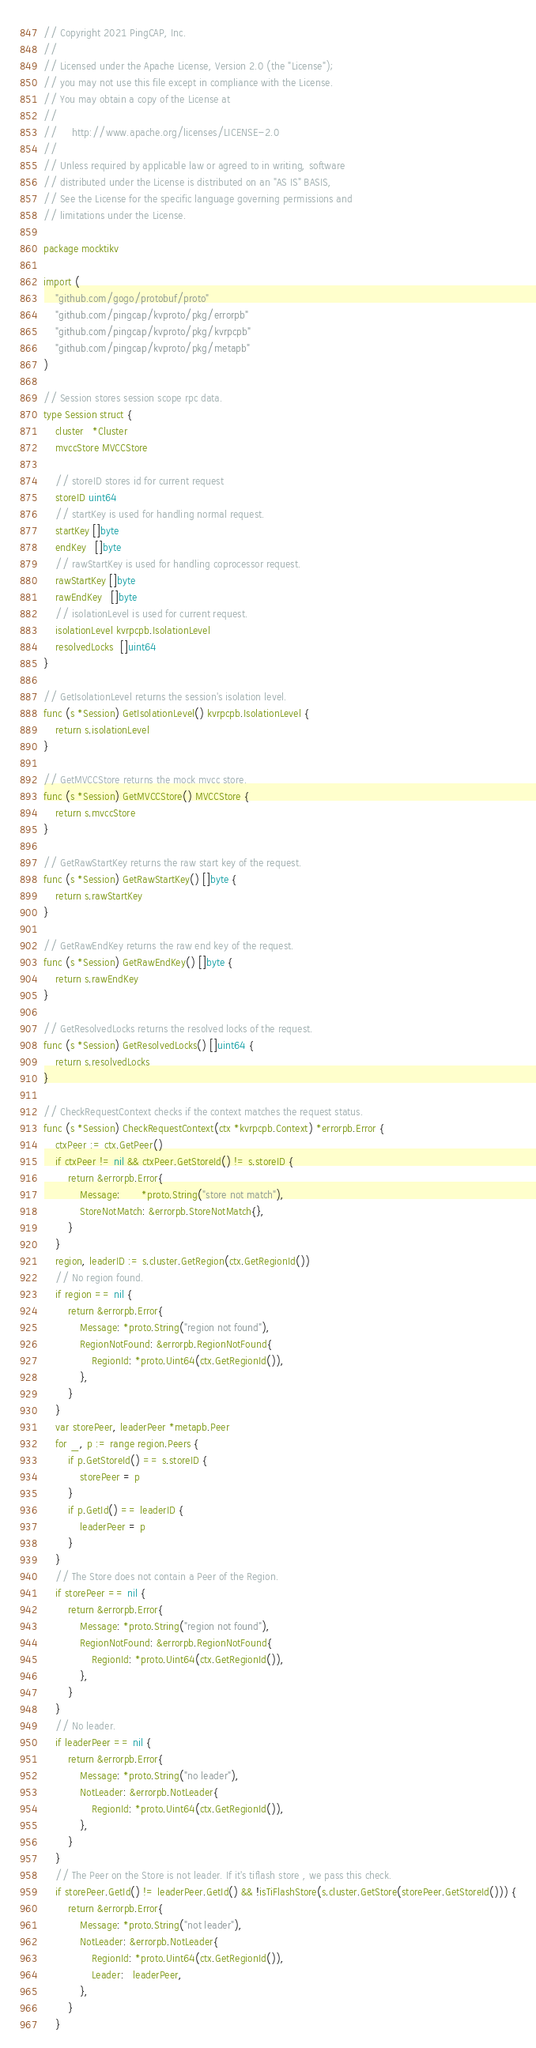<code> <loc_0><loc_0><loc_500><loc_500><_Go_>// Copyright 2021 PingCAP, Inc.
//
// Licensed under the Apache License, Version 2.0 (the "License");
// you may not use this file except in compliance with the License.
// You may obtain a copy of the License at
//
//     http://www.apache.org/licenses/LICENSE-2.0
//
// Unless required by applicable law or agreed to in writing, software
// distributed under the License is distributed on an "AS IS" BASIS,
// See the License for the specific language governing permissions and
// limitations under the License.

package mocktikv

import (
	"github.com/gogo/protobuf/proto"
	"github.com/pingcap/kvproto/pkg/errorpb"
	"github.com/pingcap/kvproto/pkg/kvrpcpb"
	"github.com/pingcap/kvproto/pkg/metapb"
)

// Session stores session scope rpc data.
type Session struct {
	cluster   *Cluster
	mvccStore MVCCStore

	// storeID stores id for current request
	storeID uint64
	// startKey is used for handling normal request.
	startKey []byte
	endKey   []byte
	// rawStartKey is used for handling coprocessor request.
	rawStartKey []byte
	rawEndKey   []byte
	// isolationLevel is used for current request.
	isolationLevel kvrpcpb.IsolationLevel
	resolvedLocks  []uint64
}

// GetIsolationLevel returns the session's isolation level.
func (s *Session) GetIsolationLevel() kvrpcpb.IsolationLevel {
	return s.isolationLevel
}

// GetMVCCStore returns the mock mvcc store.
func (s *Session) GetMVCCStore() MVCCStore {
	return s.mvccStore
}

// GetRawStartKey returns the raw start key of the request.
func (s *Session) GetRawStartKey() []byte {
	return s.rawStartKey
}

// GetRawEndKey returns the raw end key of the request.
func (s *Session) GetRawEndKey() []byte {
	return s.rawEndKey
}

// GetResolvedLocks returns the resolved locks of the request.
func (s *Session) GetResolvedLocks() []uint64 {
	return s.resolvedLocks
}

// CheckRequestContext checks if the context matches the request status.
func (s *Session) CheckRequestContext(ctx *kvrpcpb.Context) *errorpb.Error {
	ctxPeer := ctx.GetPeer()
	if ctxPeer != nil && ctxPeer.GetStoreId() != s.storeID {
		return &errorpb.Error{
			Message:       *proto.String("store not match"),
			StoreNotMatch: &errorpb.StoreNotMatch{},
		}
	}
	region, leaderID := s.cluster.GetRegion(ctx.GetRegionId())
	// No region found.
	if region == nil {
		return &errorpb.Error{
			Message: *proto.String("region not found"),
			RegionNotFound: &errorpb.RegionNotFound{
				RegionId: *proto.Uint64(ctx.GetRegionId()),
			},
		}
	}
	var storePeer, leaderPeer *metapb.Peer
	for _, p := range region.Peers {
		if p.GetStoreId() == s.storeID {
			storePeer = p
		}
		if p.GetId() == leaderID {
			leaderPeer = p
		}
	}
	// The Store does not contain a Peer of the Region.
	if storePeer == nil {
		return &errorpb.Error{
			Message: *proto.String("region not found"),
			RegionNotFound: &errorpb.RegionNotFound{
				RegionId: *proto.Uint64(ctx.GetRegionId()),
			},
		}
	}
	// No leader.
	if leaderPeer == nil {
		return &errorpb.Error{
			Message: *proto.String("no leader"),
			NotLeader: &errorpb.NotLeader{
				RegionId: *proto.Uint64(ctx.GetRegionId()),
			},
		}
	}
	// The Peer on the Store is not leader. If it's tiflash store , we pass this check.
	if storePeer.GetId() != leaderPeer.GetId() && !isTiFlashStore(s.cluster.GetStore(storePeer.GetStoreId())) {
		return &errorpb.Error{
			Message: *proto.String("not leader"),
			NotLeader: &errorpb.NotLeader{
				RegionId: *proto.Uint64(ctx.GetRegionId()),
				Leader:   leaderPeer,
			},
		}
	}</code> 